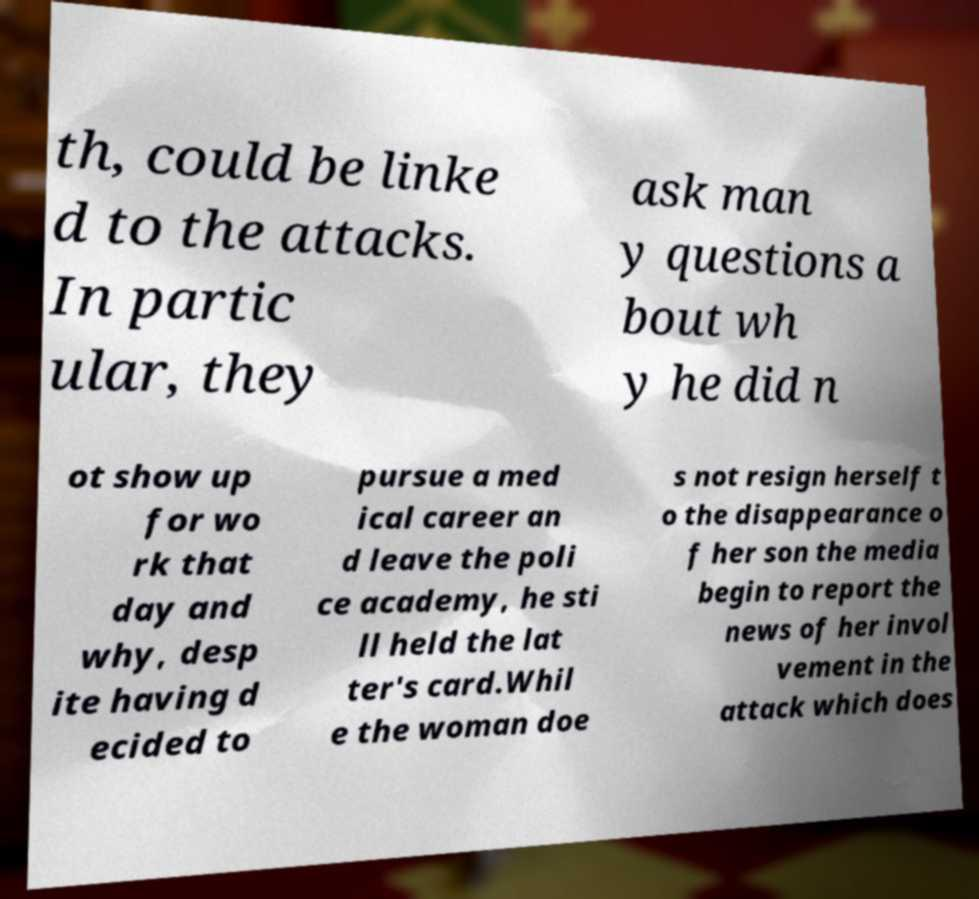For documentation purposes, I need the text within this image transcribed. Could you provide that? th, could be linke d to the attacks. In partic ular, they ask man y questions a bout wh y he did n ot show up for wo rk that day and why, desp ite having d ecided to pursue a med ical career an d leave the poli ce academy, he sti ll held the lat ter's card.Whil e the woman doe s not resign herself t o the disappearance o f her son the media begin to report the news of her invol vement in the attack which does 